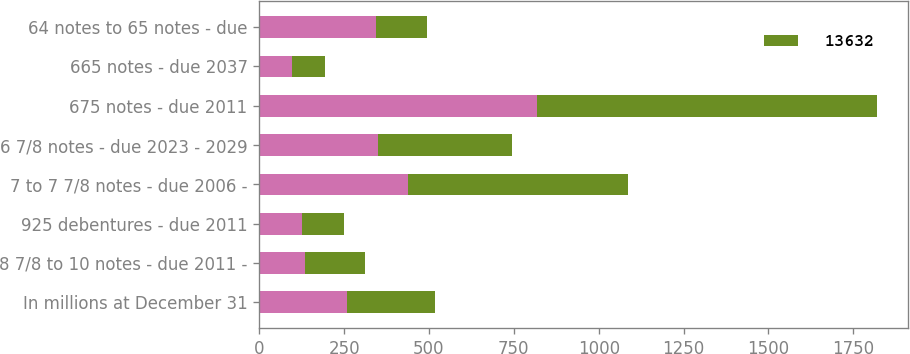Convert chart. <chart><loc_0><loc_0><loc_500><loc_500><stacked_bar_chart><ecel><fcel>In millions at December 31<fcel>8 7/8 to 10 notes - due 2011 -<fcel>925 debentures - due 2011<fcel>7 to 7 7/8 notes - due 2006 -<fcel>6 7/8 notes - due 2023 - 2029<fcel>675 notes - due 2011<fcel>665 notes - due 2037<fcel>64 notes to 65 notes - due<nl><fcel>nan<fcel>259.5<fcel>136<fcel>125<fcel>437<fcel>351<fcel>819<fcel>98<fcel>344<nl><fcel>13632<fcel>259.5<fcel>175<fcel>125<fcel>649<fcel>394<fcel>1000<fcel>97<fcel>149<nl></chart> 